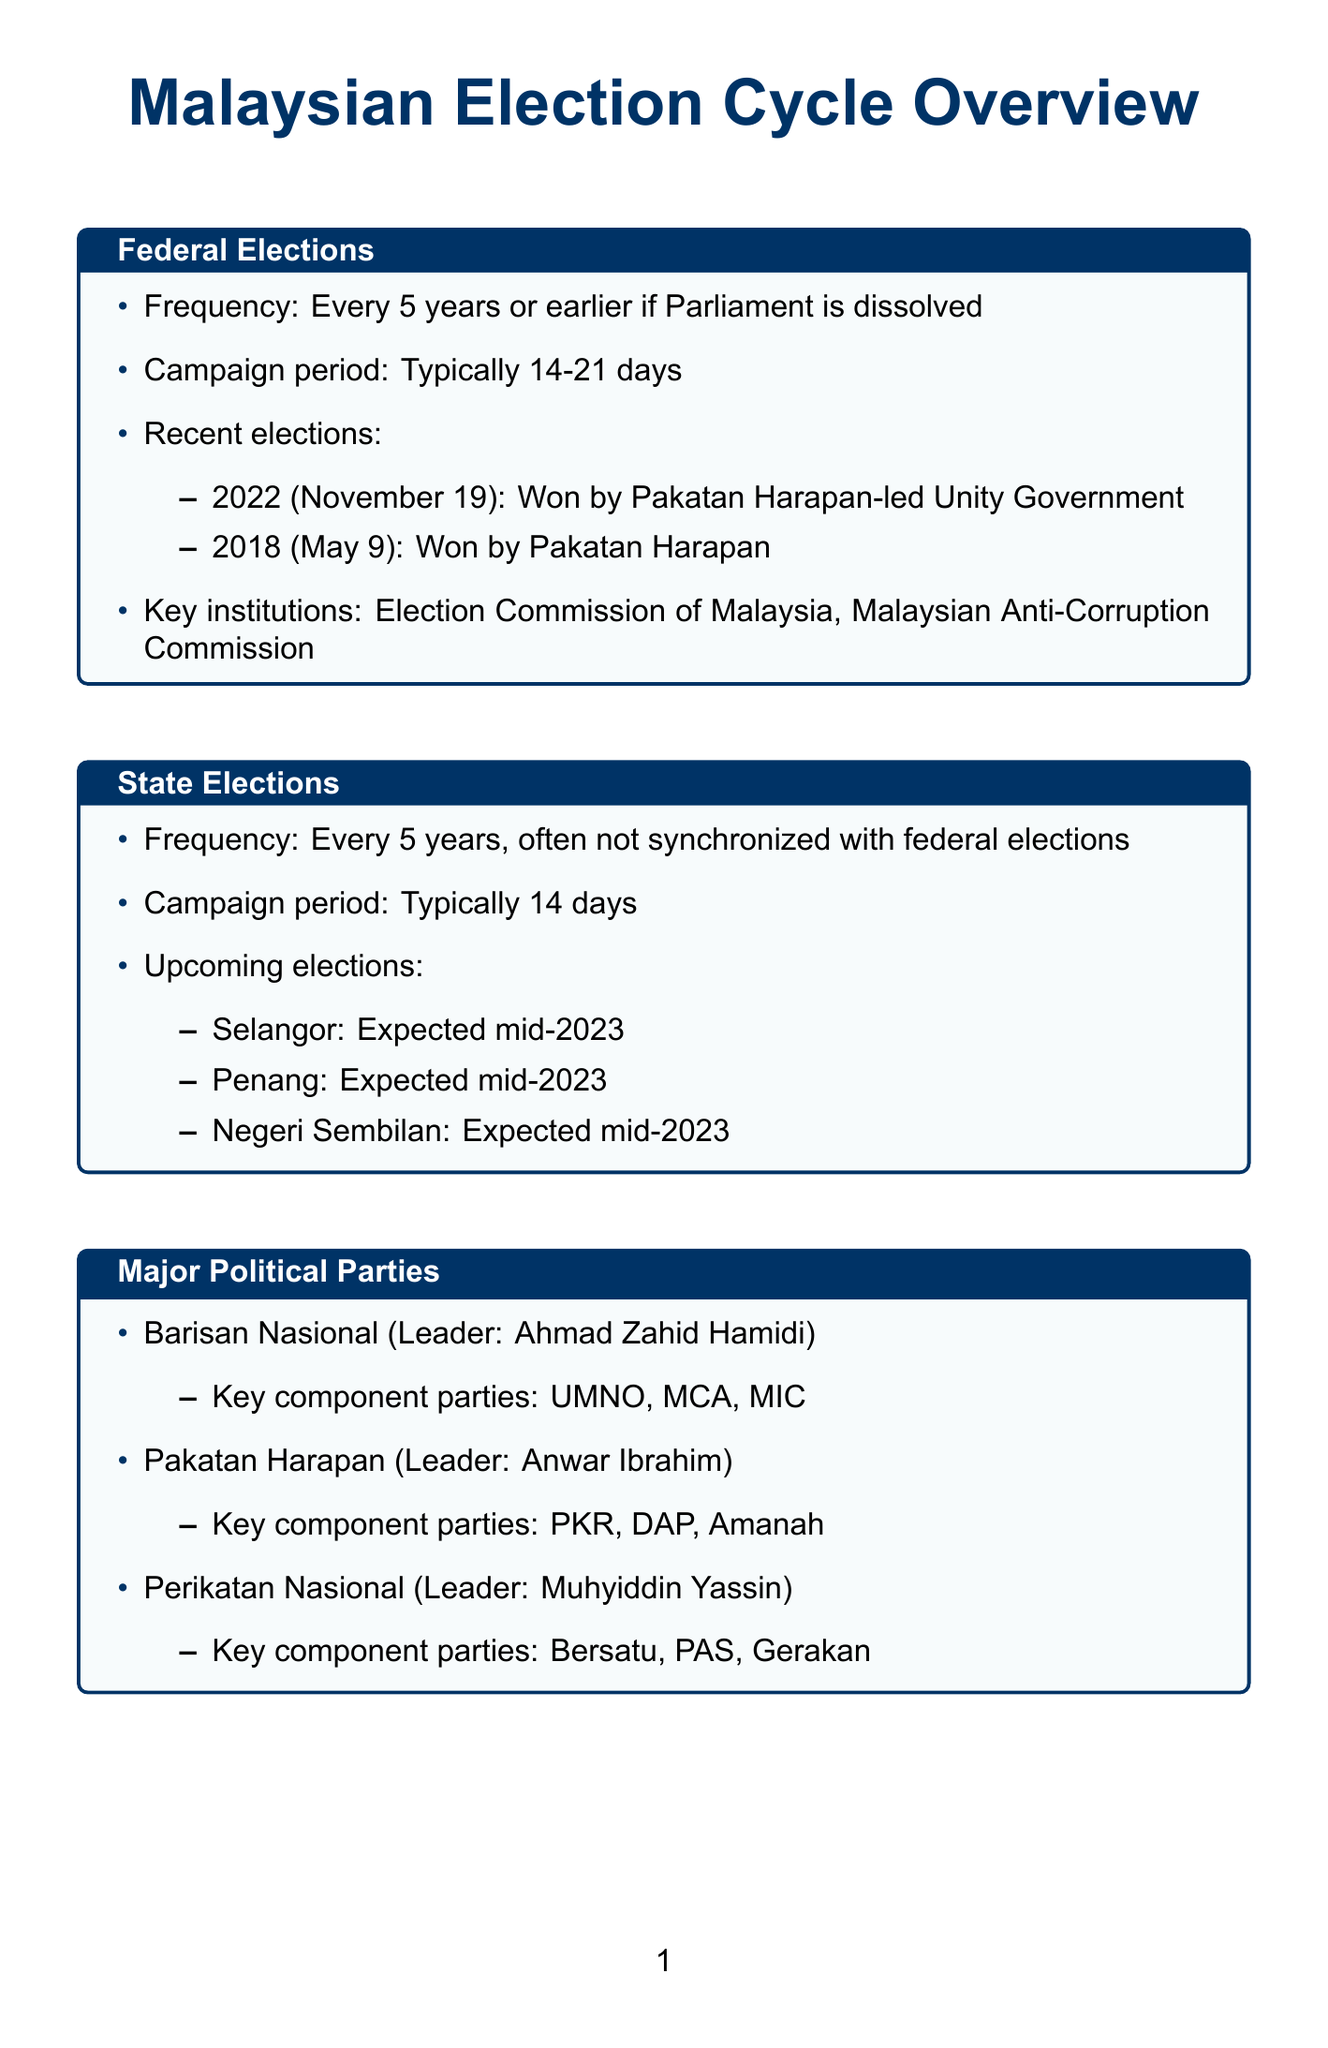What is the frequency of federal elections? The frequency of federal elections is stated as every 5 years or earlier if Parliament is dissolved.
Answer: Every 5 years What is the campaign period for state elections? The document specifies that the campaign period for state elections is typically 14 days.
Answer: 14 days Who won the recent federal election in 2022? The document lists that the Pakatan Harapan-led Unity Government won the federal election in 2022.
Answer: Pakatan Harapan-led Unity Government When are the upcoming state elections expected to take place? According to the document, the upcoming state elections are expected mid-2023.
Answer: Mid-2023 What are the key election issues mentioned? The document provides a list of various key election issues, which include economic recovery post-COVID-19, cost of living, etc.
Answer: Economic recovery post-COVID-19, cost of living, corruption and governance, race and religion, education reform Who is the leader of Pakatan Harapan? The document states that Anwar Ibrahim is the leader of Pakatan Harapan.
Answer: Anwar Ibrahim How long does the campaign period usually last for federal elections? The document indicates that the campaign period for federal elections typically lasts between 14 to 21 days.
Answer: 14-21 days What is the voting age in Malaysia as stated in the document? The document notes that the voting age was lowered from 21 to 18 in 2019.
Answer: 18 